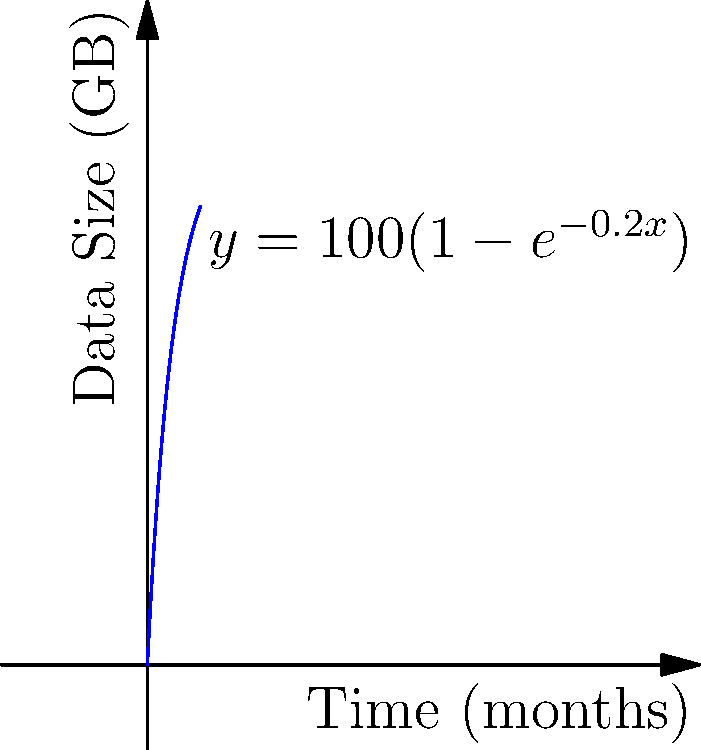As a database administrator, you're monitoring the growth of a critical database. The data size (in GB) over time (in months) follows the function $y = 100(1-e^{-0.2x})$, where $y$ is the data size and $x$ is the time. At what rate (in GB/month) is the database growing after 6 months? To find the rate of growth at 6 months, we need to calculate the derivative of the function and evaluate it at x = 6.

Step 1: Find the derivative of $y = 100(1-e^{-0.2x})$
Using the chain rule:
$\frac{dy}{dx} = 100 \cdot \frac{d}{dx}(1-e^{-0.2x})$
$\frac{dy}{dx} = 100 \cdot (0-(-0.2)e^{-0.2x})$
$\frac{dy}{dx} = 20e^{-0.2x}$

Step 2: Evaluate the derivative at x = 6
$\frac{dy}{dx}|_{x=6} = 20e^{-0.2(6)}$
$\frac{dy}{dx}|_{x=6} = 20e^{-1.2}$
$\frac{dy}{dx}|_{x=6} \approx 6.0496$ GB/month

Therefore, after 6 months, the database is growing at a rate of approximately 6.0496 GB per month.
Answer: 6.0496 GB/month 